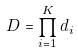<formula> <loc_0><loc_0><loc_500><loc_500>D = \prod _ { i = 1 } ^ { K } d _ { i }</formula> 